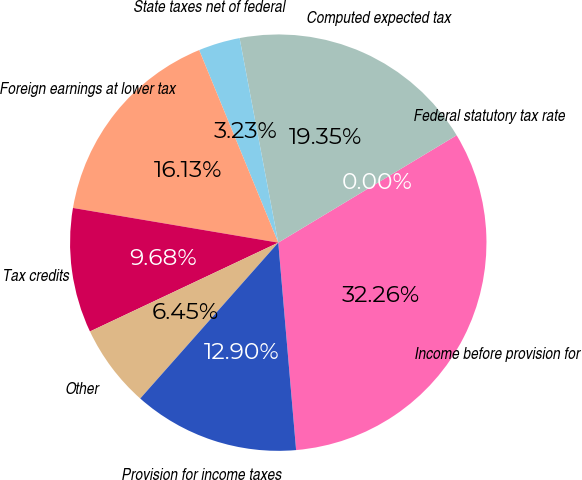Convert chart. <chart><loc_0><loc_0><loc_500><loc_500><pie_chart><fcel>Income before provision for<fcel>Federal statutory tax rate<fcel>Computed expected tax<fcel>State taxes net of federal<fcel>Foreign earnings at lower tax<fcel>Tax credits<fcel>Other<fcel>Provision for income taxes<nl><fcel>32.26%<fcel>0.0%<fcel>19.35%<fcel>3.23%<fcel>16.13%<fcel>9.68%<fcel>6.45%<fcel>12.9%<nl></chart> 